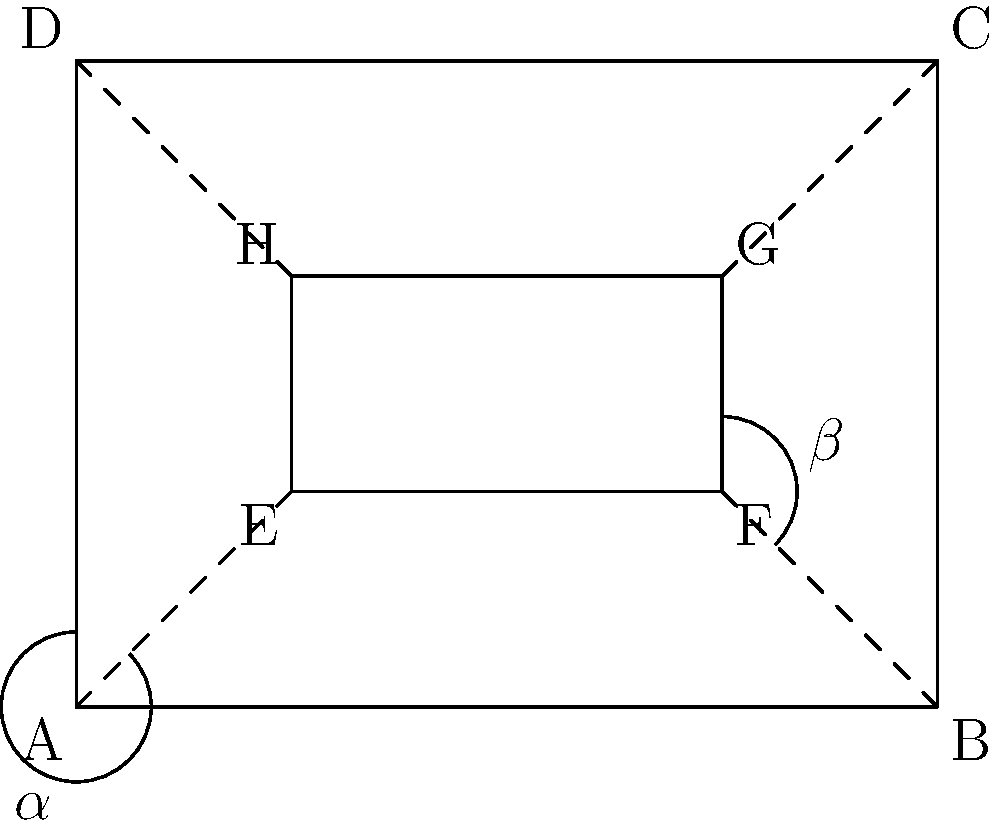In your coffee shop floor plan, you notice that the seating area EFGH is positioned at an angle within the main shop area ABCD. If angle $\alpha$ (DAE) is congruent to angle $\beta$ (BFG), what can you conclude about the positioning of the seating area relative to the shop's walls? To determine the positioning of the seating area relative to the shop's walls, we need to analyze the given information and use our knowledge of congruent angles. Let's break it down step-by-step:

1. We are told that angle $\alpha$ (DAE) is congruent to angle $\beta$ (BFG).

2. In a rectangle, all interior angles are 90°. Therefore, $\angle DAB = 90°$ and $\angle ABF = 90°$.

3. When two angles are congruent, they have the same measure. So, $\angle DAE = \angle BFG$.

4. In the diagram, we can see that:
   $\angle DAE + \angle EAB = 90°$ (they form a right angle)
   $\angle BFG + \angle ABF = 90°$ (they also form a right angle)

5. Since $\angle DAE = \angle BFG$ and both pairs sum to 90°, we can conclude that $\angle EAB = \angle ABF$.

6. This means that the angle between AE and AB is the same as the angle between BF and AB.

7. In a rectangle, opposite sides are parallel. So, AD is parallel to BC, and AB is parallel to DC.

8. If the angles between AE and AB, and BF and AB are equal, then AE must be parallel to BF.

9. By extension, this means that EF (one side of the seating area) is parallel to AB (one wall of the shop).

10. The same logic applies to the other sides, meaning that the seating area EFGH is positioned parallel to the shop's walls ABCD.
Answer: The seating area is parallel to the shop's walls. 